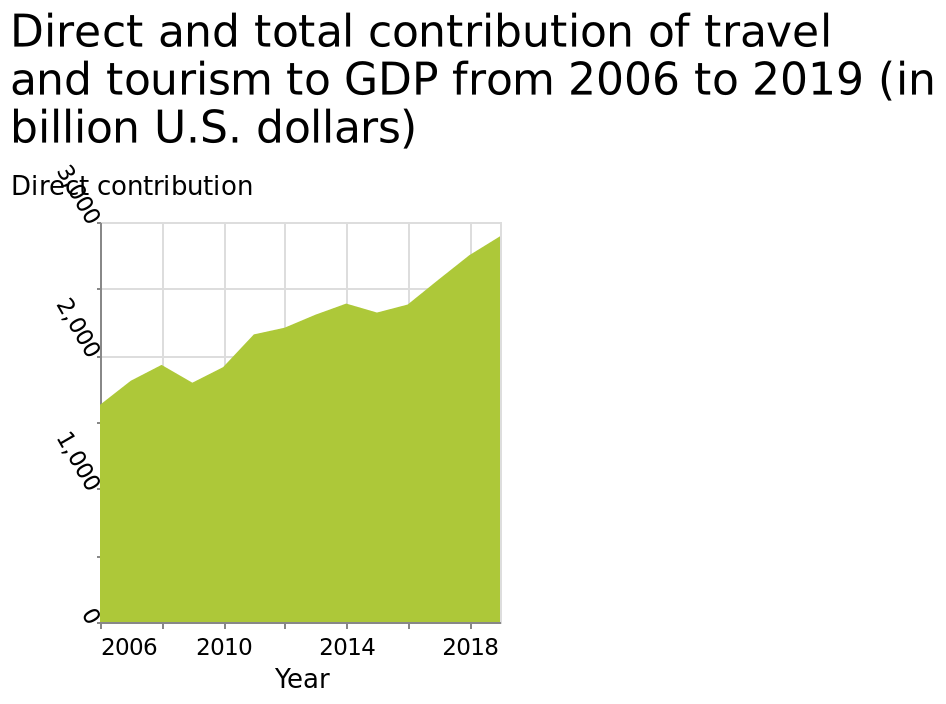<image>
How long does each phase of decrease and increase in tourism last?  Each phase of decrease and increase in tourism lasts for 2 years. 